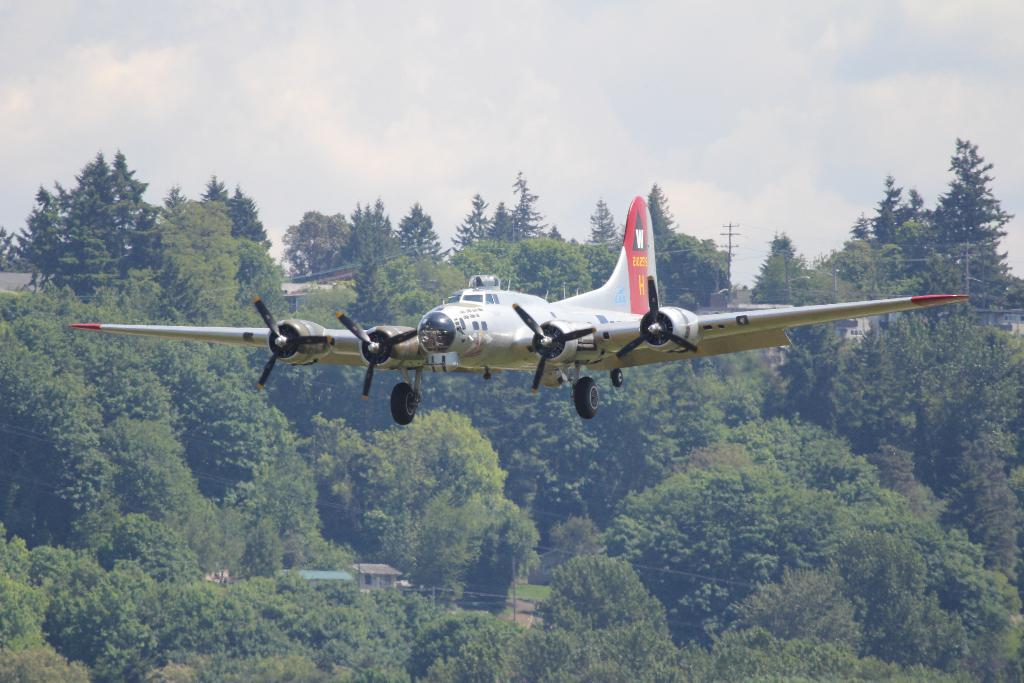What is the main subject of the image? The main subject of the image is an airplane. Where is the airplane located in the image? The airplane is in the air. What can be seen in the background of the image? There are trees, wires, poles, and houses in the background of the image. What is visible at the top of the image? The sky is visible at the top of the image. How many feet are visible on the airplane in the image? There are no feet visible on the airplane in the image, as airplanes do not have feet. Can you tell me how many crows are sitting on the wires in the background? There are no crows present in the image; only trees, wires, poles, and houses can be seen in the background. 